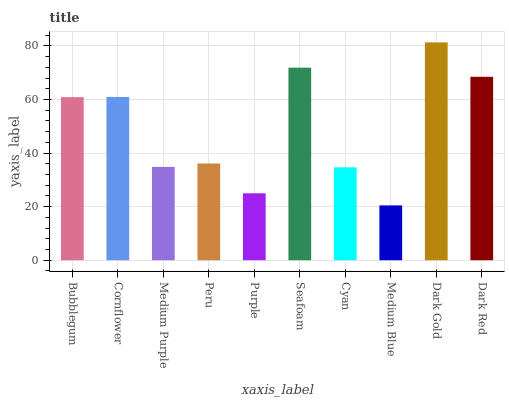Is Medium Blue the minimum?
Answer yes or no. Yes. Is Dark Gold the maximum?
Answer yes or no. Yes. Is Cornflower the minimum?
Answer yes or no. No. Is Cornflower the maximum?
Answer yes or no. No. Is Cornflower greater than Bubblegum?
Answer yes or no. Yes. Is Bubblegum less than Cornflower?
Answer yes or no. Yes. Is Bubblegum greater than Cornflower?
Answer yes or no. No. Is Cornflower less than Bubblegum?
Answer yes or no. No. Is Bubblegum the high median?
Answer yes or no. Yes. Is Peru the low median?
Answer yes or no. Yes. Is Cyan the high median?
Answer yes or no. No. Is Dark Gold the low median?
Answer yes or no. No. 